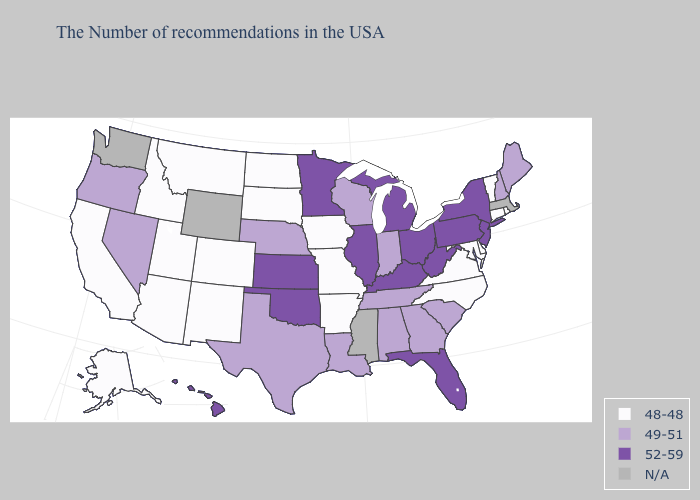What is the value of Alabama?
Be succinct. 49-51. Name the states that have a value in the range 48-48?
Keep it brief. Rhode Island, Vermont, Connecticut, Delaware, Maryland, Virginia, North Carolina, Missouri, Arkansas, Iowa, South Dakota, North Dakota, Colorado, New Mexico, Utah, Montana, Arizona, Idaho, California, Alaska. Among the states that border Michigan , does Ohio have the lowest value?
Keep it brief. No. Which states have the lowest value in the MidWest?
Quick response, please. Missouri, Iowa, South Dakota, North Dakota. What is the highest value in the Northeast ?
Keep it brief. 52-59. Does Texas have the lowest value in the USA?
Write a very short answer. No. Name the states that have a value in the range 49-51?
Write a very short answer. Maine, New Hampshire, South Carolina, Georgia, Indiana, Alabama, Tennessee, Wisconsin, Louisiana, Nebraska, Texas, Nevada, Oregon. How many symbols are there in the legend?
Concise answer only. 4. Name the states that have a value in the range 49-51?
Be succinct. Maine, New Hampshire, South Carolina, Georgia, Indiana, Alabama, Tennessee, Wisconsin, Louisiana, Nebraska, Texas, Nevada, Oregon. What is the value of Connecticut?
Write a very short answer. 48-48. Among the states that border Missouri , which have the lowest value?
Short answer required. Arkansas, Iowa. What is the lowest value in the West?
Concise answer only. 48-48. Which states hav the highest value in the MidWest?
Quick response, please. Ohio, Michigan, Illinois, Minnesota, Kansas. Does New Jersey have the highest value in the Northeast?
Give a very brief answer. Yes. What is the highest value in states that border Connecticut?
Be succinct. 52-59. 